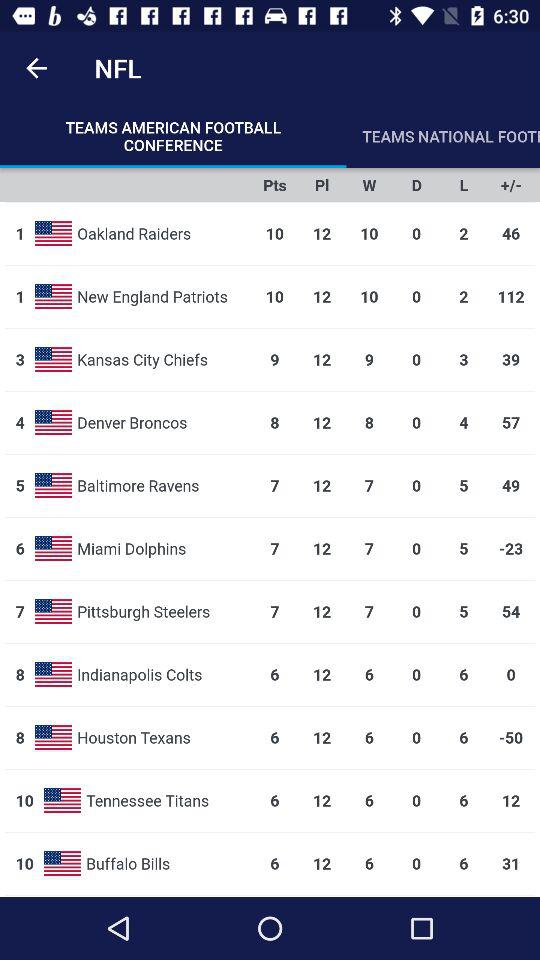Which team's score is 112? The team with a score of 112 is the "New England Patriots". 